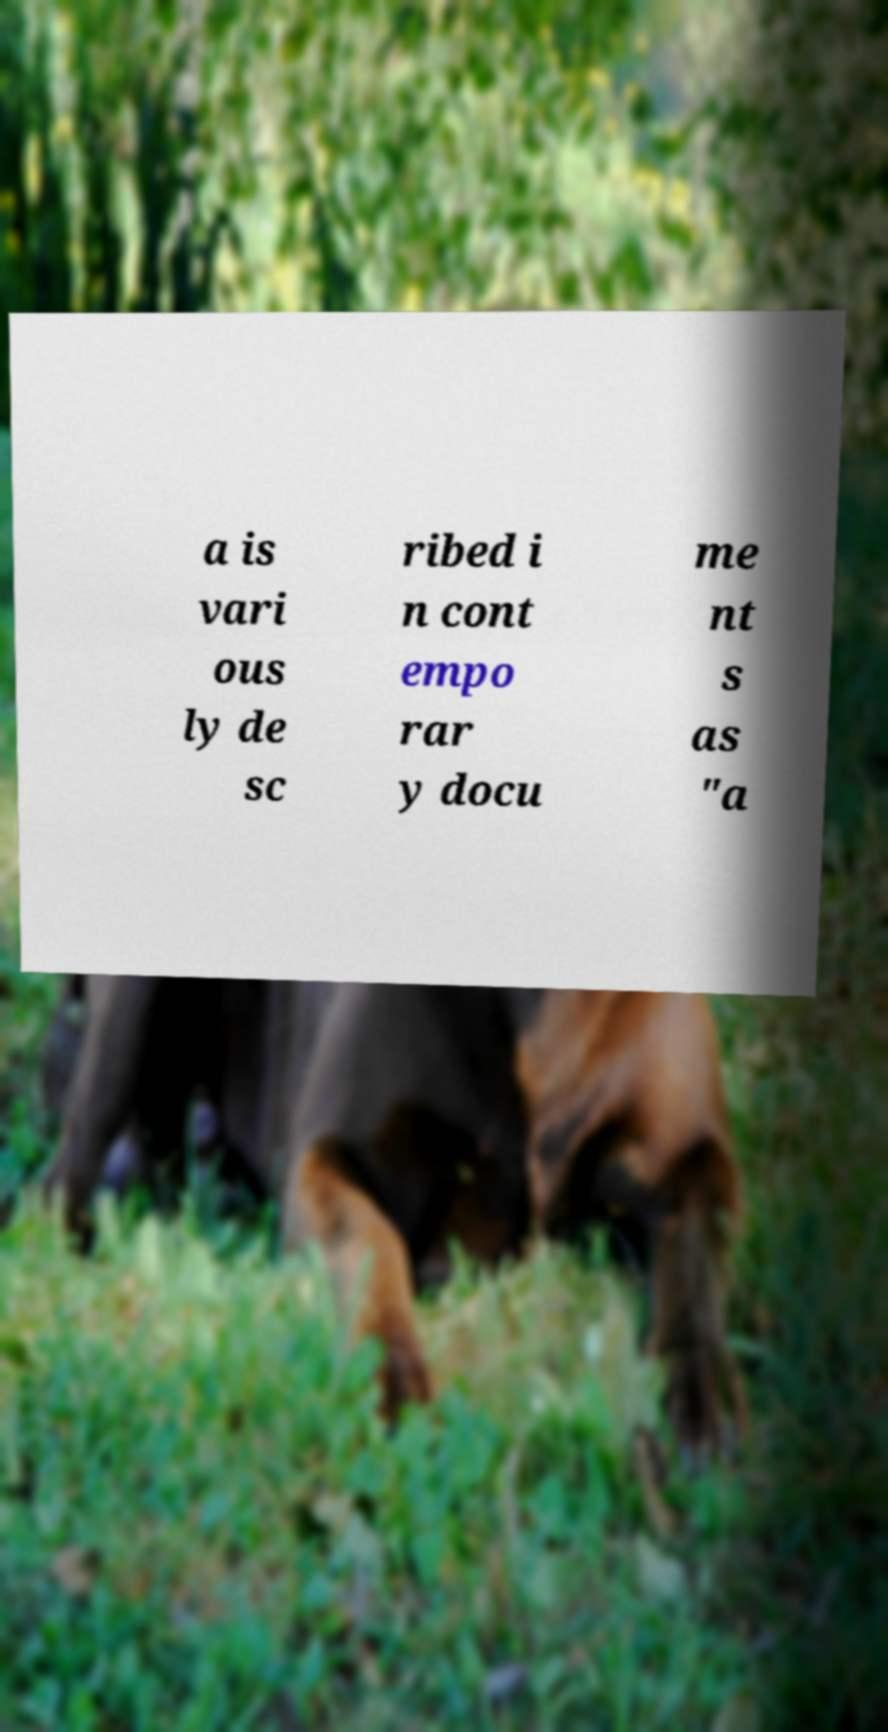What messages or text are displayed in this image? I need them in a readable, typed format. a is vari ous ly de sc ribed i n cont empo rar y docu me nt s as "a 